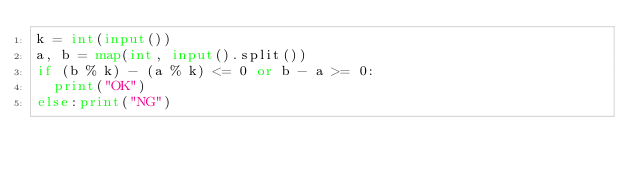<code> <loc_0><loc_0><loc_500><loc_500><_Python_>k = int(input())
a, b = map(int, input().split())
if (b % k) - (a % k) <= 0 or b - a >= 0:
  print("OK")
else:print("NG")</code> 